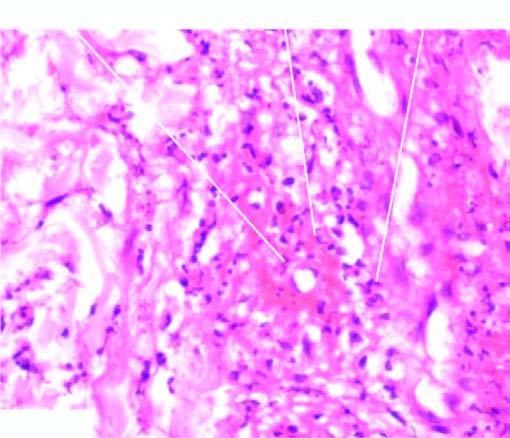does the affected area on right show brightly pink amorphous material and nuclear fragments of necrosed neutrophils?
Answer the question using a single word or phrase. No 